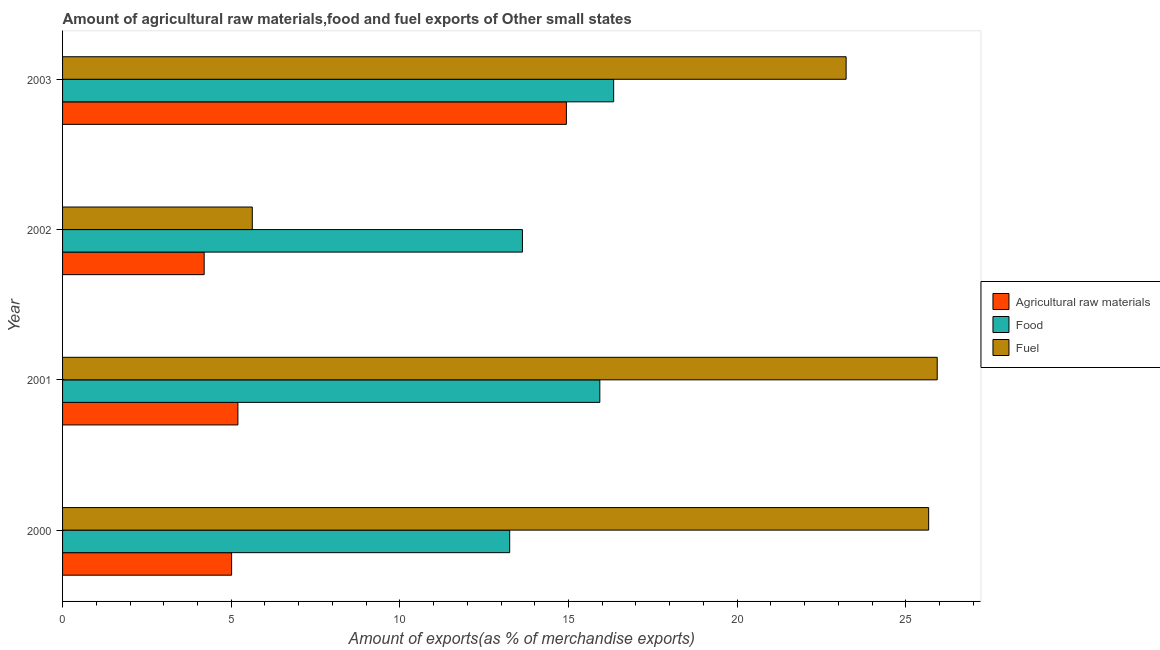How many groups of bars are there?
Your answer should be very brief. 4. What is the label of the 2nd group of bars from the top?
Make the answer very short. 2002. What is the percentage of raw materials exports in 2002?
Your answer should be compact. 4.2. Across all years, what is the maximum percentage of fuel exports?
Your response must be concise. 25.93. Across all years, what is the minimum percentage of fuel exports?
Your answer should be very brief. 5.63. In which year was the percentage of raw materials exports maximum?
Your answer should be very brief. 2003. In which year was the percentage of food exports minimum?
Your answer should be compact. 2000. What is the total percentage of raw materials exports in the graph?
Make the answer very short. 29.35. What is the difference between the percentage of food exports in 2000 and that in 2001?
Make the answer very short. -2.67. What is the difference between the percentage of food exports in 2001 and the percentage of raw materials exports in 2000?
Your answer should be very brief. 10.92. What is the average percentage of food exports per year?
Make the answer very short. 14.79. In the year 2003, what is the difference between the percentage of food exports and percentage of fuel exports?
Your response must be concise. -6.89. What is the ratio of the percentage of raw materials exports in 2000 to that in 2003?
Your answer should be very brief. 0.34. Is the percentage of raw materials exports in 2000 less than that in 2003?
Offer a terse response. Yes. Is the difference between the percentage of raw materials exports in 2000 and 2001 greater than the difference between the percentage of fuel exports in 2000 and 2001?
Ensure brevity in your answer.  Yes. What is the difference between the highest and the second highest percentage of fuel exports?
Offer a terse response. 0.25. What is the difference between the highest and the lowest percentage of fuel exports?
Offer a very short reply. 20.31. Is the sum of the percentage of raw materials exports in 2000 and 2003 greater than the maximum percentage of food exports across all years?
Keep it short and to the point. Yes. What does the 3rd bar from the top in 2002 represents?
Your response must be concise. Agricultural raw materials. What does the 2nd bar from the bottom in 2003 represents?
Your answer should be compact. Food. Is it the case that in every year, the sum of the percentage of raw materials exports and percentage of food exports is greater than the percentage of fuel exports?
Provide a succinct answer. No. Are all the bars in the graph horizontal?
Make the answer very short. Yes. Are the values on the major ticks of X-axis written in scientific E-notation?
Ensure brevity in your answer.  No. Where does the legend appear in the graph?
Offer a very short reply. Center right. How are the legend labels stacked?
Provide a short and direct response. Vertical. What is the title of the graph?
Make the answer very short. Amount of agricultural raw materials,food and fuel exports of Other small states. What is the label or title of the X-axis?
Your response must be concise. Amount of exports(as % of merchandise exports). What is the label or title of the Y-axis?
Give a very brief answer. Year. What is the Amount of exports(as % of merchandise exports) in Agricultural raw materials in 2000?
Your answer should be very brief. 5.01. What is the Amount of exports(as % of merchandise exports) in Food in 2000?
Your answer should be compact. 13.26. What is the Amount of exports(as % of merchandise exports) of Fuel in 2000?
Provide a succinct answer. 25.68. What is the Amount of exports(as % of merchandise exports) of Agricultural raw materials in 2001?
Your response must be concise. 5.2. What is the Amount of exports(as % of merchandise exports) of Food in 2001?
Offer a terse response. 15.93. What is the Amount of exports(as % of merchandise exports) of Fuel in 2001?
Your response must be concise. 25.93. What is the Amount of exports(as % of merchandise exports) of Agricultural raw materials in 2002?
Provide a succinct answer. 4.2. What is the Amount of exports(as % of merchandise exports) in Food in 2002?
Provide a short and direct response. 13.63. What is the Amount of exports(as % of merchandise exports) of Fuel in 2002?
Offer a very short reply. 5.63. What is the Amount of exports(as % of merchandise exports) of Agricultural raw materials in 2003?
Ensure brevity in your answer.  14.94. What is the Amount of exports(as % of merchandise exports) of Food in 2003?
Your answer should be very brief. 16.34. What is the Amount of exports(as % of merchandise exports) of Fuel in 2003?
Provide a short and direct response. 23.23. Across all years, what is the maximum Amount of exports(as % of merchandise exports) of Agricultural raw materials?
Provide a short and direct response. 14.94. Across all years, what is the maximum Amount of exports(as % of merchandise exports) in Food?
Your answer should be compact. 16.34. Across all years, what is the maximum Amount of exports(as % of merchandise exports) of Fuel?
Offer a terse response. 25.93. Across all years, what is the minimum Amount of exports(as % of merchandise exports) in Agricultural raw materials?
Ensure brevity in your answer.  4.2. Across all years, what is the minimum Amount of exports(as % of merchandise exports) in Food?
Ensure brevity in your answer.  13.26. Across all years, what is the minimum Amount of exports(as % of merchandise exports) of Fuel?
Give a very brief answer. 5.63. What is the total Amount of exports(as % of merchandise exports) of Agricultural raw materials in the graph?
Ensure brevity in your answer.  29.35. What is the total Amount of exports(as % of merchandise exports) of Food in the graph?
Offer a very short reply. 59.16. What is the total Amount of exports(as % of merchandise exports) in Fuel in the graph?
Keep it short and to the point. 80.47. What is the difference between the Amount of exports(as % of merchandise exports) in Agricultural raw materials in 2000 and that in 2001?
Offer a very short reply. -0.19. What is the difference between the Amount of exports(as % of merchandise exports) in Food in 2000 and that in 2001?
Your response must be concise. -2.67. What is the difference between the Amount of exports(as % of merchandise exports) of Fuel in 2000 and that in 2001?
Provide a short and direct response. -0.25. What is the difference between the Amount of exports(as % of merchandise exports) in Agricultural raw materials in 2000 and that in 2002?
Give a very brief answer. 0.81. What is the difference between the Amount of exports(as % of merchandise exports) of Food in 2000 and that in 2002?
Keep it short and to the point. -0.38. What is the difference between the Amount of exports(as % of merchandise exports) in Fuel in 2000 and that in 2002?
Your response must be concise. 20.05. What is the difference between the Amount of exports(as % of merchandise exports) of Agricultural raw materials in 2000 and that in 2003?
Offer a very short reply. -9.93. What is the difference between the Amount of exports(as % of merchandise exports) of Food in 2000 and that in 2003?
Your response must be concise. -3.08. What is the difference between the Amount of exports(as % of merchandise exports) of Fuel in 2000 and that in 2003?
Provide a short and direct response. 2.45. What is the difference between the Amount of exports(as % of merchandise exports) in Agricultural raw materials in 2001 and that in 2002?
Offer a terse response. 1. What is the difference between the Amount of exports(as % of merchandise exports) in Food in 2001 and that in 2002?
Offer a very short reply. 2.3. What is the difference between the Amount of exports(as % of merchandise exports) of Fuel in 2001 and that in 2002?
Keep it short and to the point. 20.31. What is the difference between the Amount of exports(as % of merchandise exports) of Agricultural raw materials in 2001 and that in 2003?
Your answer should be compact. -9.74. What is the difference between the Amount of exports(as % of merchandise exports) of Food in 2001 and that in 2003?
Offer a terse response. -0.41. What is the difference between the Amount of exports(as % of merchandise exports) of Fuel in 2001 and that in 2003?
Your answer should be compact. 2.7. What is the difference between the Amount of exports(as % of merchandise exports) in Agricultural raw materials in 2002 and that in 2003?
Your answer should be very brief. -10.74. What is the difference between the Amount of exports(as % of merchandise exports) in Food in 2002 and that in 2003?
Your response must be concise. -2.71. What is the difference between the Amount of exports(as % of merchandise exports) of Fuel in 2002 and that in 2003?
Offer a very short reply. -17.61. What is the difference between the Amount of exports(as % of merchandise exports) of Agricultural raw materials in 2000 and the Amount of exports(as % of merchandise exports) of Food in 2001?
Provide a succinct answer. -10.92. What is the difference between the Amount of exports(as % of merchandise exports) of Agricultural raw materials in 2000 and the Amount of exports(as % of merchandise exports) of Fuel in 2001?
Your answer should be compact. -20.92. What is the difference between the Amount of exports(as % of merchandise exports) of Food in 2000 and the Amount of exports(as % of merchandise exports) of Fuel in 2001?
Keep it short and to the point. -12.68. What is the difference between the Amount of exports(as % of merchandise exports) in Agricultural raw materials in 2000 and the Amount of exports(as % of merchandise exports) in Food in 2002?
Provide a short and direct response. -8.62. What is the difference between the Amount of exports(as % of merchandise exports) of Agricultural raw materials in 2000 and the Amount of exports(as % of merchandise exports) of Fuel in 2002?
Keep it short and to the point. -0.61. What is the difference between the Amount of exports(as % of merchandise exports) of Food in 2000 and the Amount of exports(as % of merchandise exports) of Fuel in 2002?
Offer a terse response. 7.63. What is the difference between the Amount of exports(as % of merchandise exports) of Agricultural raw materials in 2000 and the Amount of exports(as % of merchandise exports) of Food in 2003?
Your answer should be very brief. -11.33. What is the difference between the Amount of exports(as % of merchandise exports) of Agricultural raw materials in 2000 and the Amount of exports(as % of merchandise exports) of Fuel in 2003?
Give a very brief answer. -18.22. What is the difference between the Amount of exports(as % of merchandise exports) of Food in 2000 and the Amount of exports(as % of merchandise exports) of Fuel in 2003?
Offer a terse response. -9.98. What is the difference between the Amount of exports(as % of merchandise exports) of Agricultural raw materials in 2001 and the Amount of exports(as % of merchandise exports) of Food in 2002?
Offer a very short reply. -8.44. What is the difference between the Amount of exports(as % of merchandise exports) in Agricultural raw materials in 2001 and the Amount of exports(as % of merchandise exports) in Fuel in 2002?
Offer a very short reply. -0.43. What is the difference between the Amount of exports(as % of merchandise exports) in Food in 2001 and the Amount of exports(as % of merchandise exports) in Fuel in 2002?
Ensure brevity in your answer.  10.3. What is the difference between the Amount of exports(as % of merchandise exports) of Agricultural raw materials in 2001 and the Amount of exports(as % of merchandise exports) of Food in 2003?
Keep it short and to the point. -11.14. What is the difference between the Amount of exports(as % of merchandise exports) of Agricultural raw materials in 2001 and the Amount of exports(as % of merchandise exports) of Fuel in 2003?
Offer a terse response. -18.03. What is the difference between the Amount of exports(as % of merchandise exports) of Food in 2001 and the Amount of exports(as % of merchandise exports) of Fuel in 2003?
Keep it short and to the point. -7.3. What is the difference between the Amount of exports(as % of merchandise exports) of Agricultural raw materials in 2002 and the Amount of exports(as % of merchandise exports) of Food in 2003?
Provide a succinct answer. -12.14. What is the difference between the Amount of exports(as % of merchandise exports) of Agricultural raw materials in 2002 and the Amount of exports(as % of merchandise exports) of Fuel in 2003?
Your answer should be compact. -19.03. What is the difference between the Amount of exports(as % of merchandise exports) in Food in 2002 and the Amount of exports(as % of merchandise exports) in Fuel in 2003?
Provide a short and direct response. -9.6. What is the average Amount of exports(as % of merchandise exports) of Agricultural raw materials per year?
Your answer should be very brief. 7.34. What is the average Amount of exports(as % of merchandise exports) in Food per year?
Provide a succinct answer. 14.79. What is the average Amount of exports(as % of merchandise exports) of Fuel per year?
Provide a succinct answer. 20.12. In the year 2000, what is the difference between the Amount of exports(as % of merchandise exports) in Agricultural raw materials and Amount of exports(as % of merchandise exports) in Food?
Ensure brevity in your answer.  -8.24. In the year 2000, what is the difference between the Amount of exports(as % of merchandise exports) of Agricultural raw materials and Amount of exports(as % of merchandise exports) of Fuel?
Offer a very short reply. -20.67. In the year 2000, what is the difference between the Amount of exports(as % of merchandise exports) in Food and Amount of exports(as % of merchandise exports) in Fuel?
Keep it short and to the point. -12.42. In the year 2001, what is the difference between the Amount of exports(as % of merchandise exports) in Agricultural raw materials and Amount of exports(as % of merchandise exports) in Food?
Ensure brevity in your answer.  -10.73. In the year 2001, what is the difference between the Amount of exports(as % of merchandise exports) in Agricultural raw materials and Amount of exports(as % of merchandise exports) in Fuel?
Your answer should be very brief. -20.73. In the year 2001, what is the difference between the Amount of exports(as % of merchandise exports) in Food and Amount of exports(as % of merchandise exports) in Fuel?
Provide a short and direct response. -10. In the year 2002, what is the difference between the Amount of exports(as % of merchandise exports) in Agricultural raw materials and Amount of exports(as % of merchandise exports) in Food?
Provide a succinct answer. -9.44. In the year 2002, what is the difference between the Amount of exports(as % of merchandise exports) of Agricultural raw materials and Amount of exports(as % of merchandise exports) of Fuel?
Give a very brief answer. -1.43. In the year 2002, what is the difference between the Amount of exports(as % of merchandise exports) in Food and Amount of exports(as % of merchandise exports) in Fuel?
Your answer should be compact. 8.01. In the year 2003, what is the difference between the Amount of exports(as % of merchandise exports) in Agricultural raw materials and Amount of exports(as % of merchandise exports) in Food?
Give a very brief answer. -1.4. In the year 2003, what is the difference between the Amount of exports(as % of merchandise exports) of Agricultural raw materials and Amount of exports(as % of merchandise exports) of Fuel?
Keep it short and to the point. -8.29. In the year 2003, what is the difference between the Amount of exports(as % of merchandise exports) in Food and Amount of exports(as % of merchandise exports) in Fuel?
Ensure brevity in your answer.  -6.89. What is the ratio of the Amount of exports(as % of merchandise exports) in Food in 2000 to that in 2001?
Make the answer very short. 0.83. What is the ratio of the Amount of exports(as % of merchandise exports) of Fuel in 2000 to that in 2001?
Offer a terse response. 0.99. What is the ratio of the Amount of exports(as % of merchandise exports) of Agricultural raw materials in 2000 to that in 2002?
Provide a short and direct response. 1.19. What is the ratio of the Amount of exports(as % of merchandise exports) of Food in 2000 to that in 2002?
Your answer should be very brief. 0.97. What is the ratio of the Amount of exports(as % of merchandise exports) of Fuel in 2000 to that in 2002?
Give a very brief answer. 4.56. What is the ratio of the Amount of exports(as % of merchandise exports) of Agricultural raw materials in 2000 to that in 2003?
Your response must be concise. 0.34. What is the ratio of the Amount of exports(as % of merchandise exports) in Food in 2000 to that in 2003?
Your response must be concise. 0.81. What is the ratio of the Amount of exports(as % of merchandise exports) of Fuel in 2000 to that in 2003?
Provide a short and direct response. 1.11. What is the ratio of the Amount of exports(as % of merchandise exports) in Agricultural raw materials in 2001 to that in 2002?
Your answer should be very brief. 1.24. What is the ratio of the Amount of exports(as % of merchandise exports) in Food in 2001 to that in 2002?
Your answer should be compact. 1.17. What is the ratio of the Amount of exports(as % of merchandise exports) of Fuel in 2001 to that in 2002?
Provide a short and direct response. 4.61. What is the ratio of the Amount of exports(as % of merchandise exports) of Agricultural raw materials in 2001 to that in 2003?
Ensure brevity in your answer.  0.35. What is the ratio of the Amount of exports(as % of merchandise exports) of Food in 2001 to that in 2003?
Ensure brevity in your answer.  0.97. What is the ratio of the Amount of exports(as % of merchandise exports) in Fuel in 2001 to that in 2003?
Offer a very short reply. 1.12. What is the ratio of the Amount of exports(as % of merchandise exports) of Agricultural raw materials in 2002 to that in 2003?
Your answer should be very brief. 0.28. What is the ratio of the Amount of exports(as % of merchandise exports) of Food in 2002 to that in 2003?
Keep it short and to the point. 0.83. What is the ratio of the Amount of exports(as % of merchandise exports) of Fuel in 2002 to that in 2003?
Offer a very short reply. 0.24. What is the difference between the highest and the second highest Amount of exports(as % of merchandise exports) of Agricultural raw materials?
Offer a terse response. 9.74. What is the difference between the highest and the second highest Amount of exports(as % of merchandise exports) of Food?
Give a very brief answer. 0.41. What is the difference between the highest and the second highest Amount of exports(as % of merchandise exports) of Fuel?
Offer a terse response. 0.25. What is the difference between the highest and the lowest Amount of exports(as % of merchandise exports) in Agricultural raw materials?
Provide a succinct answer. 10.74. What is the difference between the highest and the lowest Amount of exports(as % of merchandise exports) in Food?
Your answer should be very brief. 3.08. What is the difference between the highest and the lowest Amount of exports(as % of merchandise exports) in Fuel?
Offer a terse response. 20.31. 